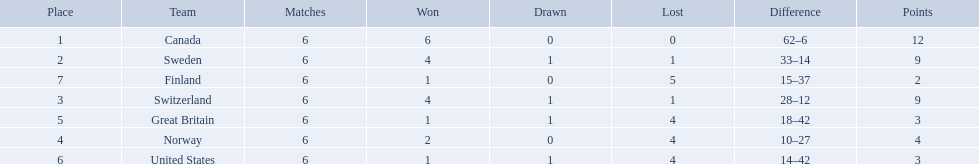Which are the two countries? Switzerland, Great Britain. What were the point totals for each of these countries? 9, 3. Of these point totals, which is better? 9. Which country earned this point total? Switzerland. 